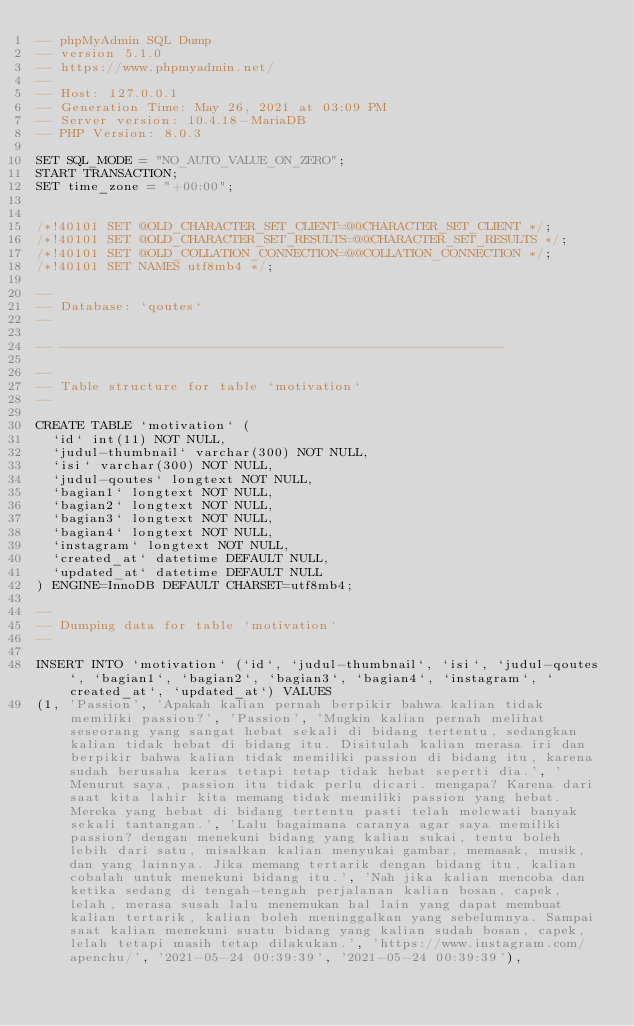Convert code to text. <code><loc_0><loc_0><loc_500><loc_500><_SQL_>-- phpMyAdmin SQL Dump
-- version 5.1.0
-- https://www.phpmyadmin.net/
--
-- Host: 127.0.0.1
-- Generation Time: May 26, 2021 at 03:09 PM
-- Server version: 10.4.18-MariaDB
-- PHP Version: 8.0.3

SET SQL_MODE = "NO_AUTO_VALUE_ON_ZERO";
START TRANSACTION;
SET time_zone = "+00:00";


/*!40101 SET @OLD_CHARACTER_SET_CLIENT=@@CHARACTER_SET_CLIENT */;
/*!40101 SET @OLD_CHARACTER_SET_RESULTS=@@CHARACTER_SET_RESULTS */;
/*!40101 SET @OLD_COLLATION_CONNECTION=@@COLLATION_CONNECTION */;
/*!40101 SET NAMES utf8mb4 */;

--
-- Database: `qoutes`
--

-- --------------------------------------------------------

--
-- Table structure for table `motivation`
--

CREATE TABLE `motivation` (
  `id` int(11) NOT NULL,
  `judul-thumbnail` varchar(300) NOT NULL,
  `isi` varchar(300) NOT NULL,
  `judul-qoutes` longtext NOT NULL,
  `bagian1` longtext NOT NULL,
  `bagian2` longtext NOT NULL,
  `bagian3` longtext NOT NULL,
  `bagian4` longtext NOT NULL,
  `instagram` longtext NOT NULL,
  `created_at` datetime DEFAULT NULL,
  `updated_at` datetime DEFAULT NULL
) ENGINE=InnoDB DEFAULT CHARSET=utf8mb4;

--
-- Dumping data for table `motivation`
--

INSERT INTO `motivation` (`id`, `judul-thumbnail`, `isi`, `judul-qoutes`, `bagian1`, `bagian2`, `bagian3`, `bagian4`, `instagram`, `created_at`, `updated_at`) VALUES
(1, 'Passion', 'Apakah kalian pernah berpikir bahwa kalian tidak memiliki passion?', 'Passion', 'Mugkin kalian pernah melihat seseorang yang sangat hebat sekali di bidang tertentu, sedangkan kalian tidak hebat di bidang itu. Disitulah kalian merasa iri dan berpikir bahwa kalian tidak memiliki passion di bidang itu, karena sudah berusaha keras tetapi tetap tidak hebat seperti dia.', 'Menurut saya, passion itu tidak perlu dicari. mengapa? Karena dari saat kita lahir kita memang tidak memiliki passion yang hebat. Mereka yang hebat di bidang tertentu pasti telah melewati banyak sekali tantangan.', 'Lalu bagaimana caranya agar saya memiliki passion? dengan menekuni bidang yang kalian sukai, tentu boleh lebih dari satu, misalkan kalian menyukai gambar, memasak, musik, dan yang lainnya. Jika memang tertarik dengan bidang itu, kalian cobalah untuk menekuni bidang itu.', 'Nah jika kalian mencoba dan ketika sedang di tengah-tengah perjalanan kalian bosan, capek, lelah, merasa susah lalu menemukan hal lain yang dapat membuat kalian tertarik, kalian boleh meninggalkan yang sebelumnya. Sampai saat kalian menekuni suatu bidang yang kalian sudah bosan, capek, lelah tetapi masih tetap dilakukan.', 'https://www.instagram.com/apenchu/', '2021-05-24 00:39:39', '2021-05-24 00:39:39'),</code> 